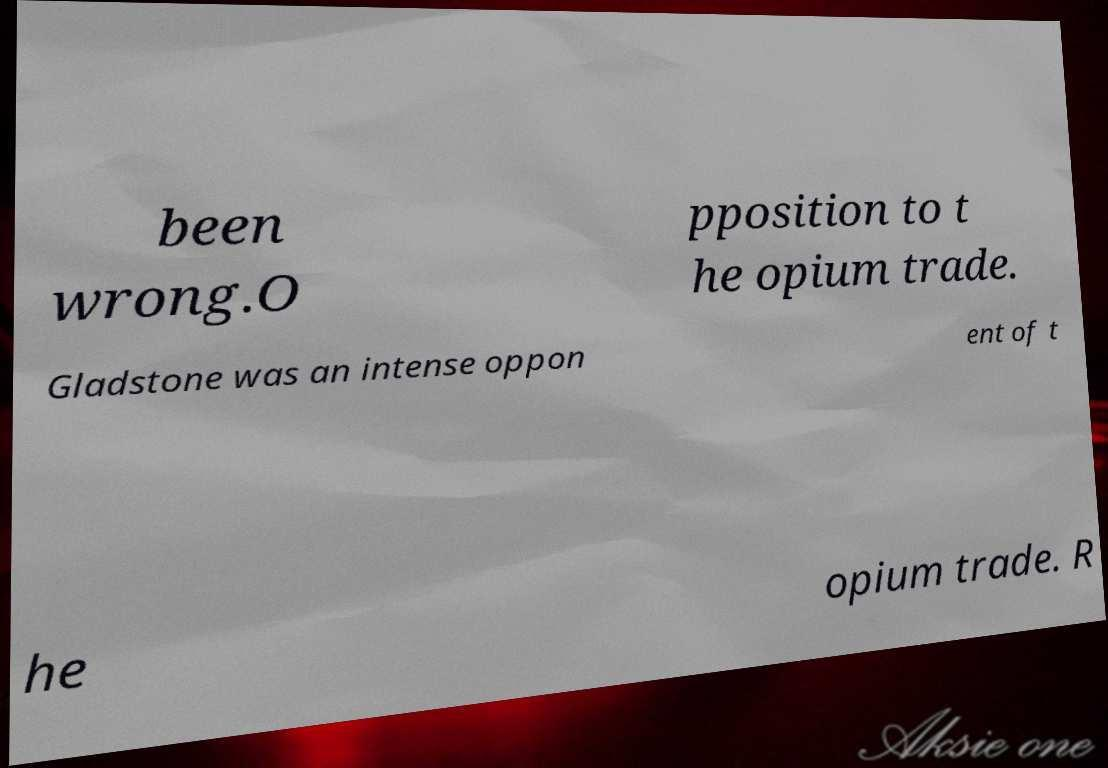Could you assist in decoding the text presented in this image and type it out clearly? been wrong.O pposition to t he opium trade. Gladstone was an intense oppon ent of t he opium trade. R 